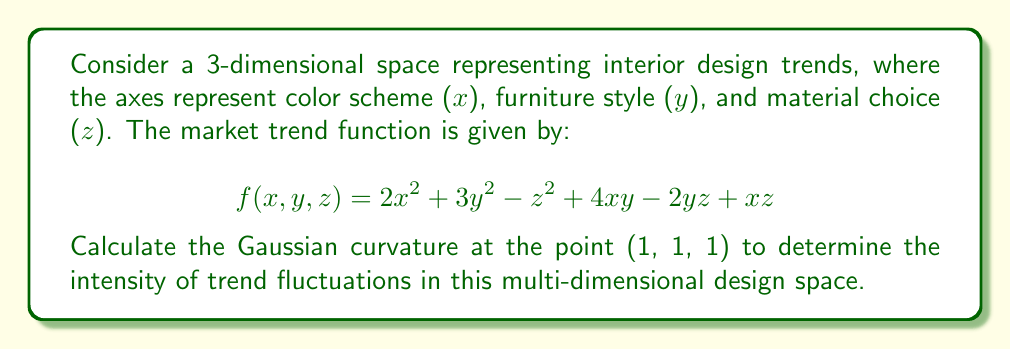Give your solution to this math problem. To find the Gaussian curvature, we need to calculate the following steps:

1) First, compute the first and second partial derivatives:
   $$f_x = 4x + 4y + z$$
   $$f_y = 6y + 4x - 2z$$
   $$f_z = -2z + x - 2y$$
   
   $$f_{xx} = 4$$
   $$f_{yy} = 6$$
   $$f_{zz} = -2$$
   $$f_{xy} = f_{yx} = 4$$
   $$f_{xz} = f_{zx} = 1$$
   $$f_{yz} = f_{zy} = -2$$

2) Calculate the normal vector:
   $$\vec{N} = \nabla f = (f_x, f_y, f_z) = (4x + 4y + z, 6y + 4x - 2z, -2z + x - 2y)$$

3) At point (1, 1, 1):
   $$\vec{N} = (9, 8, -3)$$

4) Compute the magnitude of the normal vector:
   $$|\vec{N}| = \sqrt{9^2 + 8^2 + (-3)^2} = \sqrt{154}$$

5) Calculate the coefficients of the first fundamental form:
   $$E = 1 + f_x^2 = 82$$
   $$F = f_x f_y = 72$$
   $$G = 1 + f_y^2 = 65$$

6) Calculate the coefficients of the second fundamental form:
   $$e = \frac{f_{xx}}{|\vec{N}|} = \frac{4}{\sqrt{154}}$$
   $$f = \frac{f_{xy}}{|\vec{N}|} = \frac{4}{\sqrt{154}}$$
   $$g = \frac{f_{yy}}{|\vec{N}|} = \frac{6}{\sqrt{154}}$$

7) Compute the Gaussian curvature:
   $$K = \frac{eg - f^2}{EG - F^2}$$

8) Substitute the values:
   $$K = \frac{(\frac{4}{\sqrt{154}})(\frac{6}{\sqrt{154}}) - (\frac{4}{\sqrt{154}})^2}{(82)(65) - 72^2}$$

9) Simplify:
   $$K = \frac{24 - 16}{154(5330 - 5184)} = \frac{8}{22484} = \frac{1}{2810.5}$$
Answer: $\frac{1}{2810.5}$ 